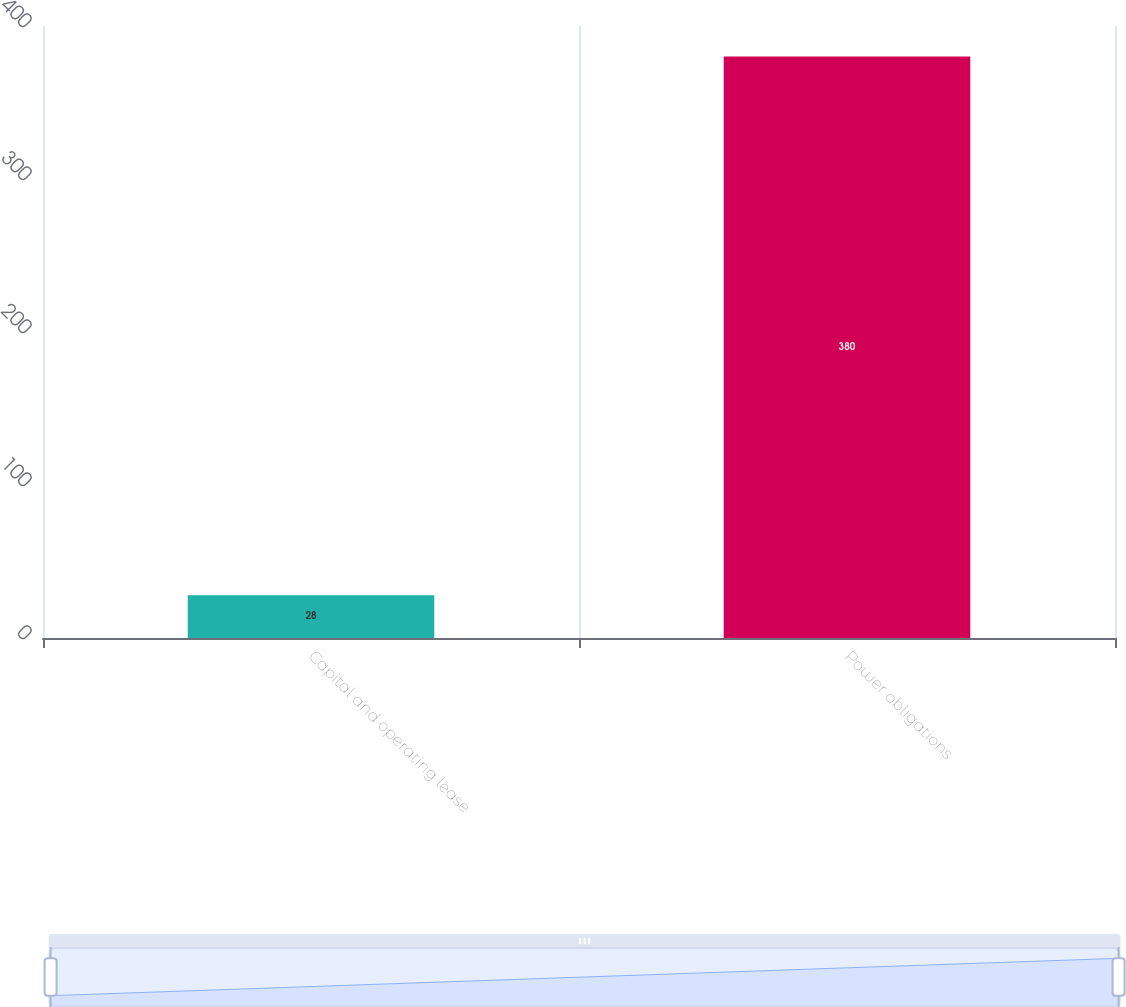Convert chart to OTSL. <chart><loc_0><loc_0><loc_500><loc_500><bar_chart><fcel>Capital and operating lease<fcel>Power obligations<nl><fcel>28<fcel>380<nl></chart> 